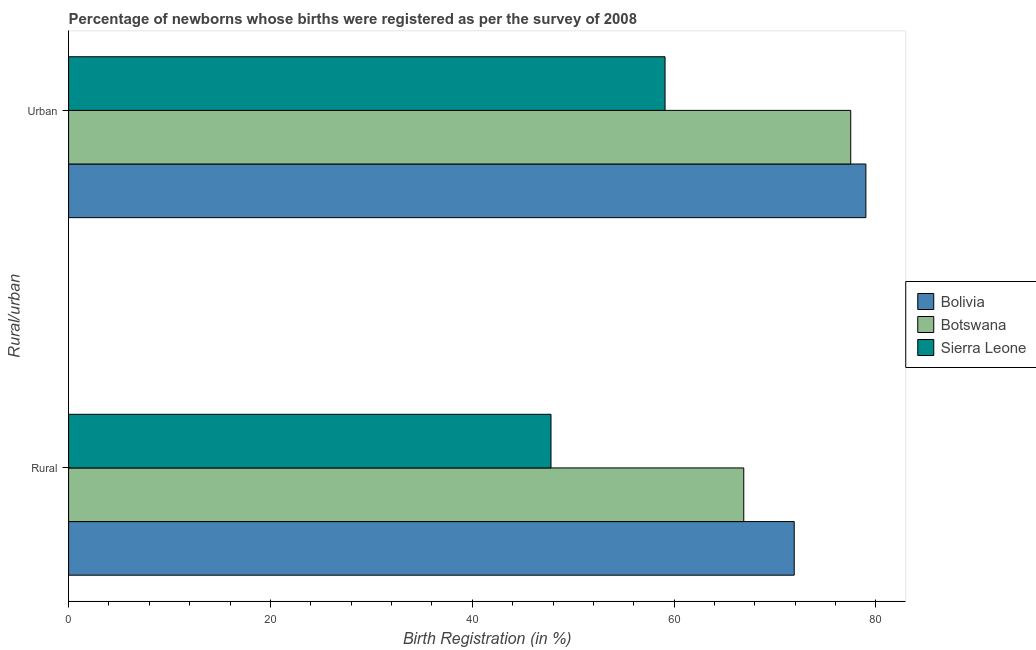How many different coloured bars are there?
Give a very brief answer. 3. Are the number of bars per tick equal to the number of legend labels?
Offer a terse response. Yes. Are the number of bars on each tick of the Y-axis equal?
Make the answer very short. Yes. What is the label of the 2nd group of bars from the top?
Provide a short and direct response. Rural. What is the urban birth registration in Botswana?
Keep it short and to the point. 77.5. Across all countries, what is the maximum urban birth registration?
Make the answer very short. 79. Across all countries, what is the minimum urban birth registration?
Provide a succinct answer. 59.1. In which country was the rural birth registration maximum?
Keep it short and to the point. Bolivia. In which country was the rural birth registration minimum?
Provide a succinct answer. Sierra Leone. What is the total rural birth registration in the graph?
Provide a succinct answer. 186.6. What is the difference between the urban birth registration in Sierra Leone and that in Bolivia?
Ensure brevity in your answer.  -19.9. What is the difference between the rural birth registration in Bolivia and the urban birth registration in Botswana?
Your answer should be compact. -5.6. What is the average rural birth registration per country?
Give a very brief answer. 62.2. What is the difference between the urban birth registration and rural birth registration in Botswana?
Your response must be concise. 10.6. In how many countries, is the rural birth registration greater than 64 %?
Offer a very short reply. 2. What is the ratio of the urban birth registration in Sierra Leone to that in Botswana?
Your response must be concise. 0.76. In how many countries, is the rural birth registration greater than the average rural birth registration taken over all countries?
Keep it short and to the point. 2. What does the 3rd bar from the top in Rural represents?
Give a very brief answer. Bolivia. What does the 1st bar from the bottom in Urban represents?
Provide a succinct answer. Bolivia. How many bars are there?
Offer a terse response. 6. How many countries are there in the graph?
Your answer should be compact. 3. What is the difference between two consecutive major ticks on the X-axis?
Make the answer very short. 20. Does the graph contain grids?
Your response must be concise. No. Where does the legend appear in the graph?
Ensure brevity in your answer.  Center right. How many legend labels are there?
Ensure brevity in your answer.  3. How are the legend labels stacked?
Your answer should be very brief. Vertical. What is the title of the graph?
Keep it short and to the point. Percentage of newborns whose births were registered as per the survey of 2008. What is the label or title of the X-axis?
Give a very brief answer. Birth Registration (in %). What is the label or title of the Y-axis?
Provide a short and direct response. Rural/urban. What is the Birth Registration (in %) of Bolivia in Rural?
Offer a very short reply. 71.9. What is the Birth Registration (in %) of Botswana in Rural?
Keep it short and to the point. 66.9. What is the Birth Registration (in %) of Sierra Leone in Rural?
Your answer should be compact. 47.8. What is the Birth Registration (in %) in Bolivia in Urban?
Your answer should be very brief. 79. What is the Birth Registration (in %) in Botswana in Urban?
Keep it short and to the point. 77.5. What is the Birth Registration (in %) in Sierra Leone in Urban?
Provide a succinct answer. 59.1. Across all Rural/urban, what is the maximum Birth Registration (in %) in Bolivia?
Offer a terse response. 79. Across all Rural/urban, what is the maximum Birth Registration (in %) of Botswana?
Provide a succinct answer. 77.5. Across all Rural/urban, what is the maximum Birth Registration (in %) in Sierra Leone?
Offer a terse response. 59.1. Across all Rural/urban, what is the minimum Birth Registration (in %) of Bolivia?
Your answer should be compact. 71.9. Across all Rural/urban, what is the minimum Birth Registration (in %) in Botswana?
Give a very brief answer. 66.9. Across all Rural/urban, what is the minimum Birth Registration (in %) in Sierra Leone?
Offer a very short reply. 47.8. What is the total Birth Registration (in %) of Bolivia in the graph?
Provide a succinct answer. 150.9. What is the total Birth Registration (in %) in Botswana in the graph?
Offer a terse response. 144.4. What is the total Birth Registration (in %) of Sierra Leone in the graph?
Offer a very short reply. 106.9. What is the difference between the Birth Registration (in %) of Botswana in Rural and that in Urban?
Offer a terse response. -10.6. What is the difference between the Birth Registration (in %) of Sierra Leone in Rural and that in Urban?
Give a very brief answer. -11.3. What is the average Birth Registration (in %) of Bolivia per Rural/urban?
Your answer should be very brief. 75.45. What is the average Birth Registration (in %) of Botswana per Rural/urban?
Keep it short and to the point. 72.2. What is the average Birth Registration (in %) in Sierra Leone per Rural/urban?
Offer a terse response. 53.45. What is the difference between the Birth Registration (in %) of Bolivia and Birth Registration (in %) of Botswana in Rural?
Your response must be concise. 5. What is the difference between the Birth Registration (in %) of Bolivia and Birth Registration (in %) of Sierra Leone in Rural?
Keep it short and to the point. 24.1. What is the difference between the Birth Registration (in %) of Bolivia and Birth Registration (in %) of Sierra Leone in Urban?
Your answer should be compact. 19.9. What is the ratio of the Birth Registration (in %) in Bolivia in Rural to that in Urban?
Ensure brevity in your answer.  0.91. What is the ratio of the Birth Registration (in %) of Botswana in Rural to that in Urban?
Give a very brief answer. 0.86. What is the ratio of the Birth Registration (in %) of Sierra Leone in Rural to that in Urban?
Offer a very short reply. 0.81. What is the difference between the highest and the lowest Birth Registration (in %) of Bolivia?
Your answer should be very brief. 7.1. 